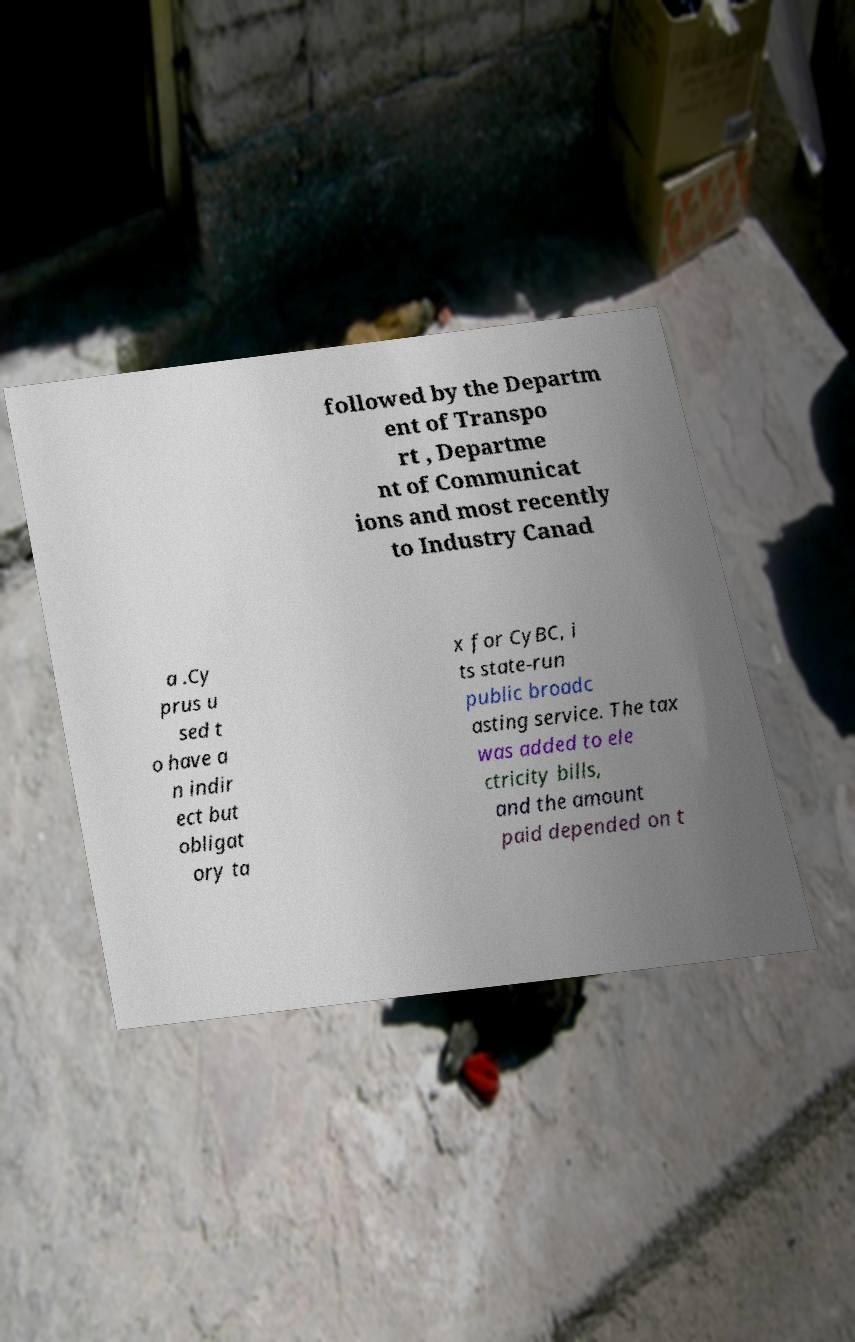Could you assist in decoding the text presented in this image and type it out clearly? followed by the Departm ent of Transpo rt , Departme nt of Communicat ions and most recently to Industry Canad a .Cy prus u sed t o have a n indir ect but obligat ory ta x for CyBC, i ts state-run public broadc asting service. The tax was added to ele ctricity bills, and the amount paid depended on t 